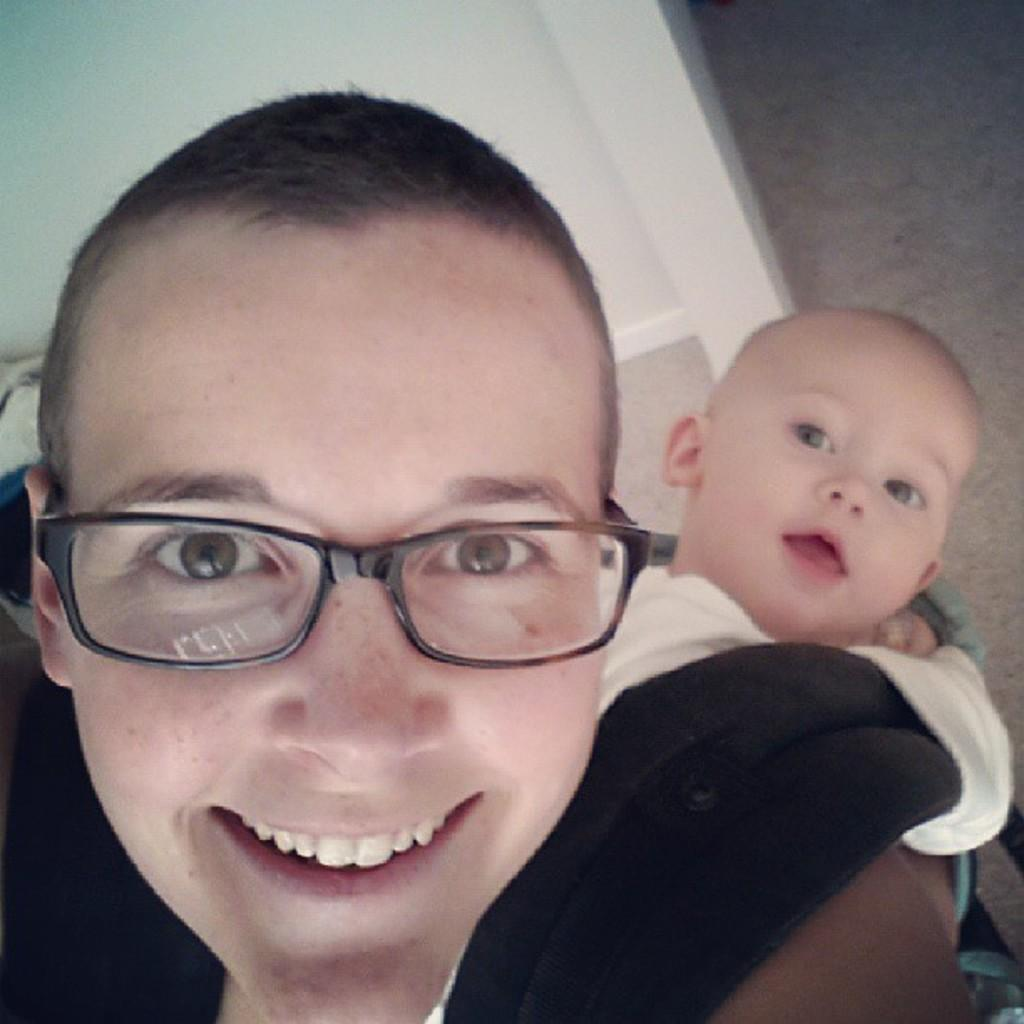How many people are in the image? There are two persons in the image. Can you describe the object behind the persons? There is a white object visible behind the persons. What type of bird is perched on the icicle in the image? There is no bird or icicle present in the image. What color is the van parked behind the persons in the image? There is no van present in the image. 